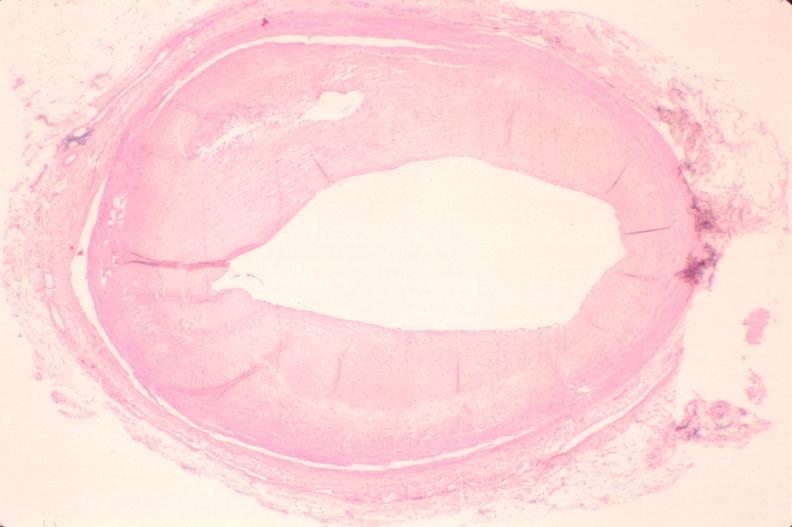what does this image show?
Answer the question using a single word or phrase. Atherosclerosis 